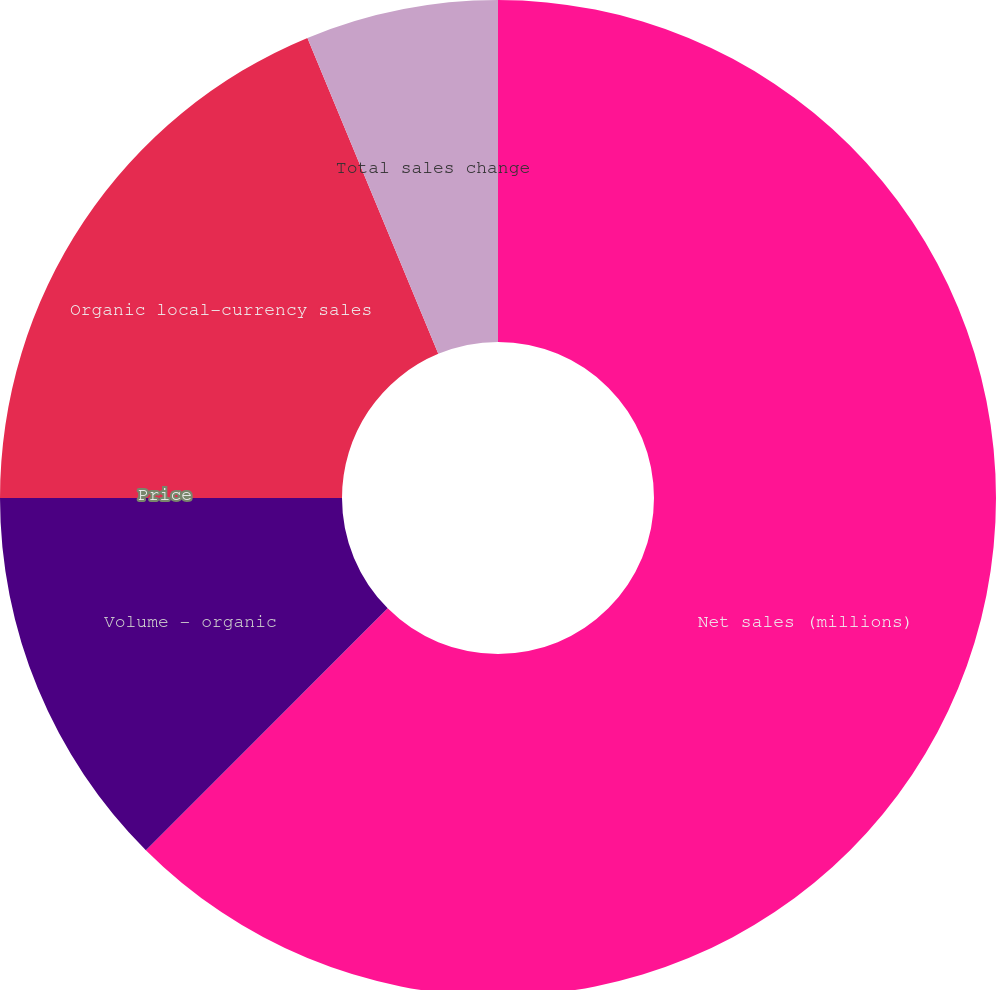<chart> <loc_0><loc_0><loc_500><loc_500><pie_chart><fcel>Net sales (millions)<fcel>Volume - organic<fcel>Price<fcel>Organic local-currency sales<fcel>Total sales change<nl><fcel>62.5%<fcel>12.5%<fcel>0.0%<fcel>18.75%<fcel>6.25%<nl></chart> 